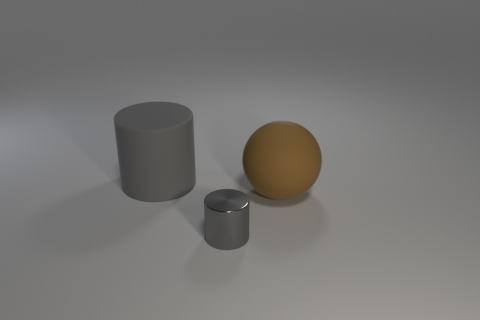Is the number of shiny objects in front of the brown matte thing less than the number of metallic objects?
Your response must be concise. No. Do the big thing on the left side of the tiny gray metallic object and the shiny cylinder have the same color?
Keep it short and to the point. Yes. How many shiny things are either tiny cylinders or gray things?
Your response must be concise. 1. Is there any other thing that has the same size as the metal object?
Provide a succinct answer. No. What is the color of the other large object that is made of the same material as the big brown thing?
Make the answer very short. Gray. How many cylinders are blue shiny things or brown things?
Ensure brevity in your answer.  0. How many things are either red metallic cylinders or cylinders on the right side of the big cylinder?
Your response must be concise. 1. Are there any brown blocks?
Offer a terse response. No. How many things have the same color as the matte cylinder?
Your answer should be very brief. 1. What material is the object that is the same color as the rubber cylinder?
Offer a very short reply. Metal. 